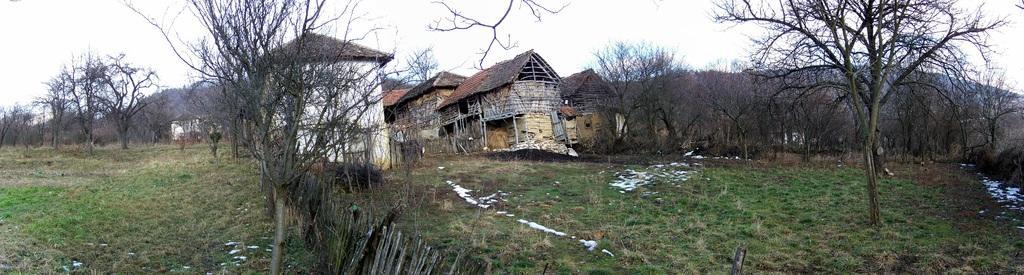Describe this image in one or two sentences. In this image we can see some trees, grass there are some houses which are in the shape of huts and in the background of the image there are some mountains and clear sky. 